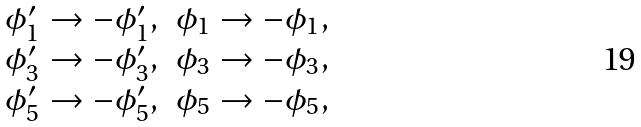Convert formula to latex. <formula><loc_0><loc_0><loc_500><loc_500>\begin{matrix} \phi _ { 1 } ^ { \prime } \rightarrow - \phi _ { 1 } ^ { \prime } , & \phi _ { 1 } \rightarrow - \phi _ { 1 } , \\ \phi _ { 3 } ^ { \prime } \rightarrow - \phi _ { 3 } ^ { \prime } , & \phi _ { 3 } \rightarrow - \phi _ { 3 } , \\ \phi _ { 5 } ^ { \prime } \rightarrow - \phi _ { 5 } ^ { \prime } , & \phi _ { 5 } \rightarrow - \phi _ { 5 } , \end{matrix}</formula> 